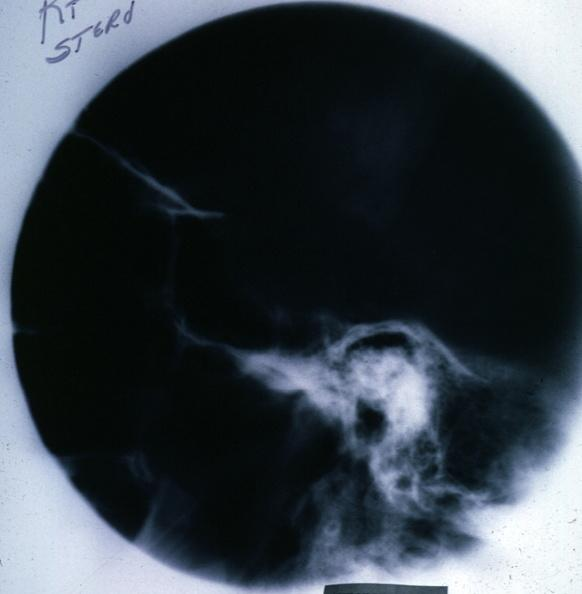what is present?
Answer the question using a single word or phrase. Chromophobe adenoma 